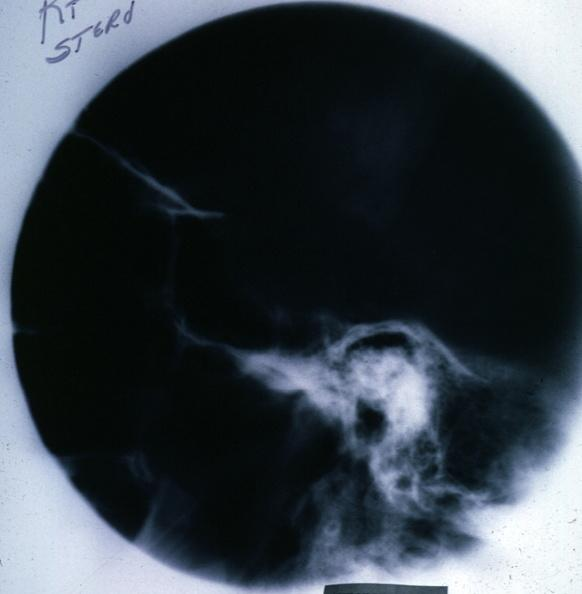what is present?
Answer the question using a single word or phrase. Chromophobe adenoma 